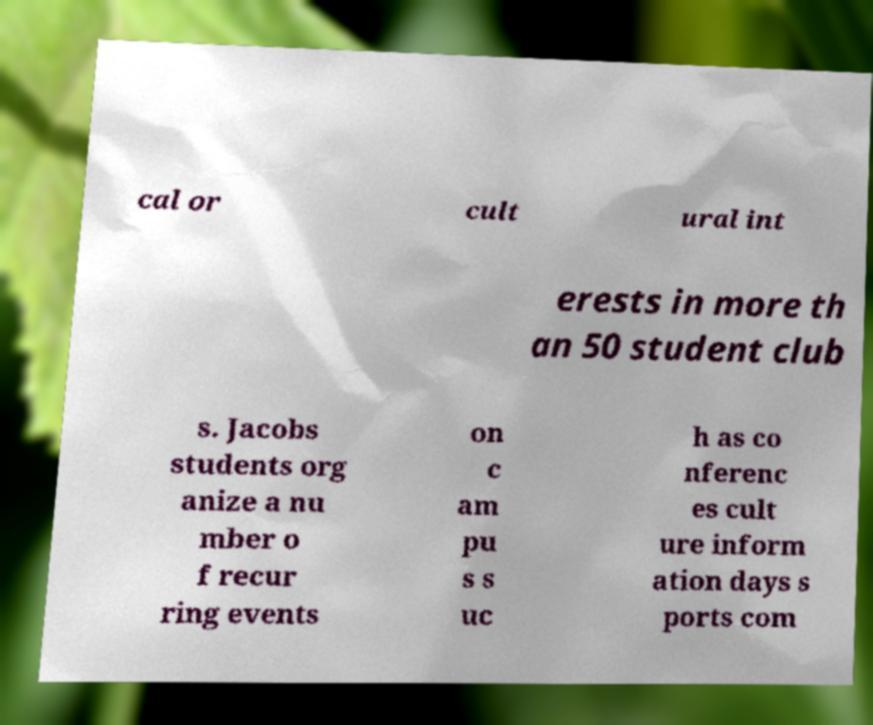Can you read and provide the text displayed in the image?This photo seems to have some interesting text. Can you extract and type it out for me? cal or cult ural int erests in more th an 50 student club s. Jacobs students org anize a nu mber o f recur ring events on c am pu s s uc h as co nferenc es cult ure inform ation days s ports com 